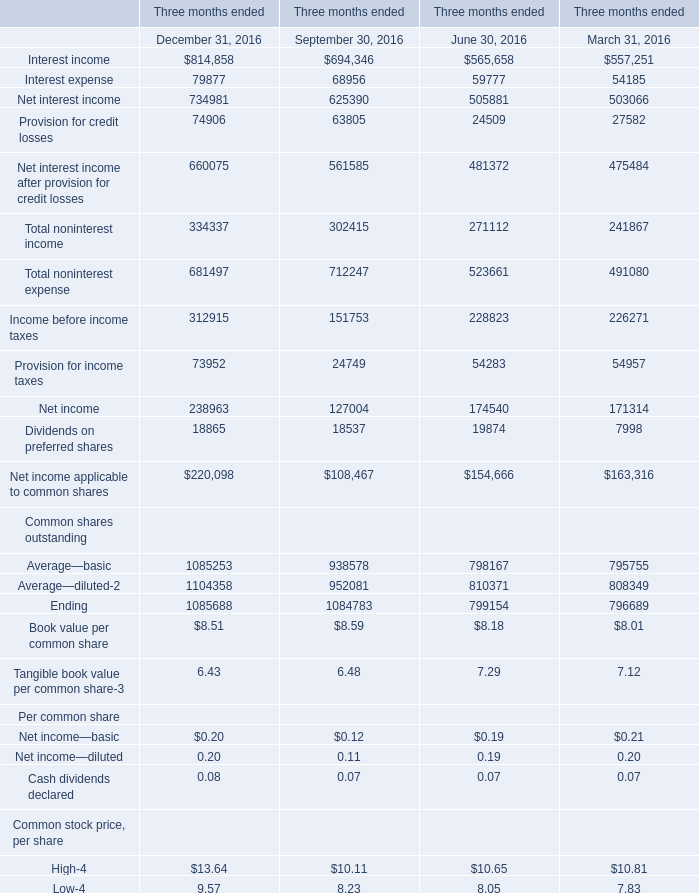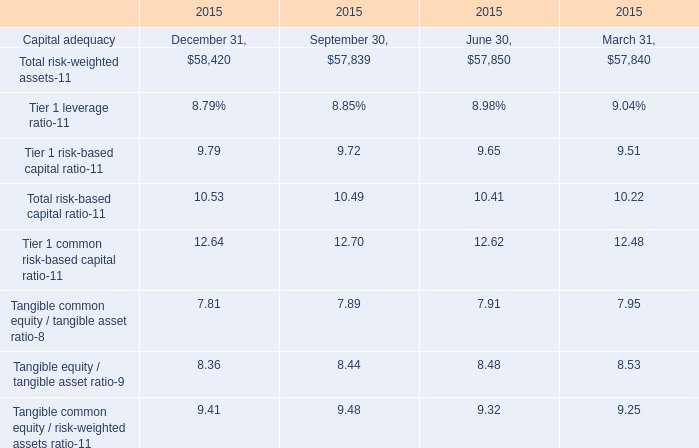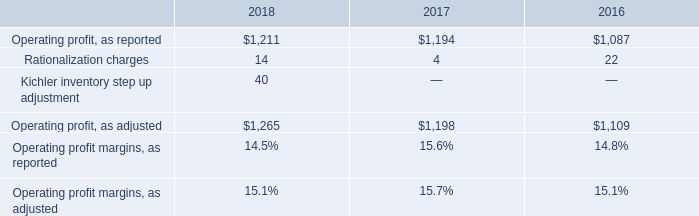What is the average amount of Operating profit, as adjusted of 2018, and Net interest income of Three months ended March 31, 2016 ? 
Computations: ((1265.0 + 503066.0) / 2)
Answer: 252165.5. 